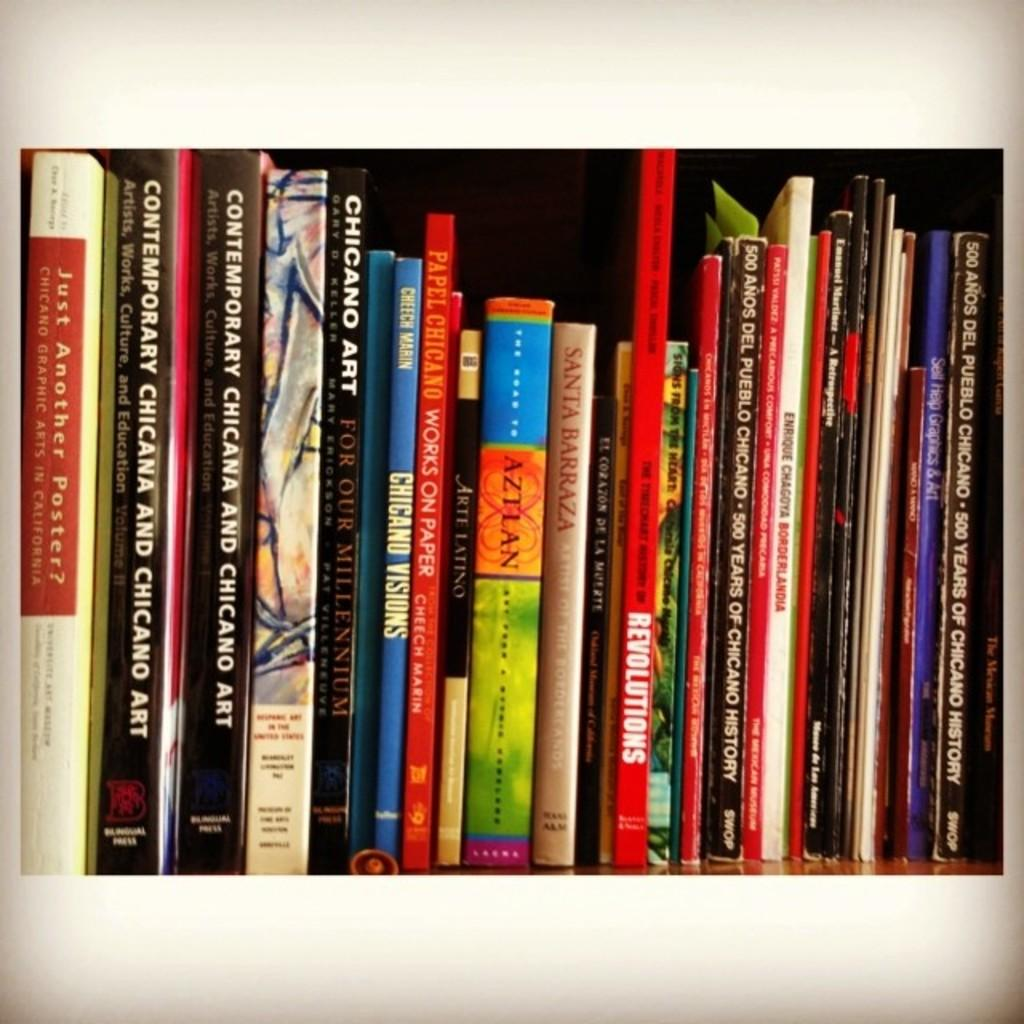<image>
Give a short and clear explanation of the subsequent image. Many colorful books like Aztlan and Chicago art displayed on a shelf 